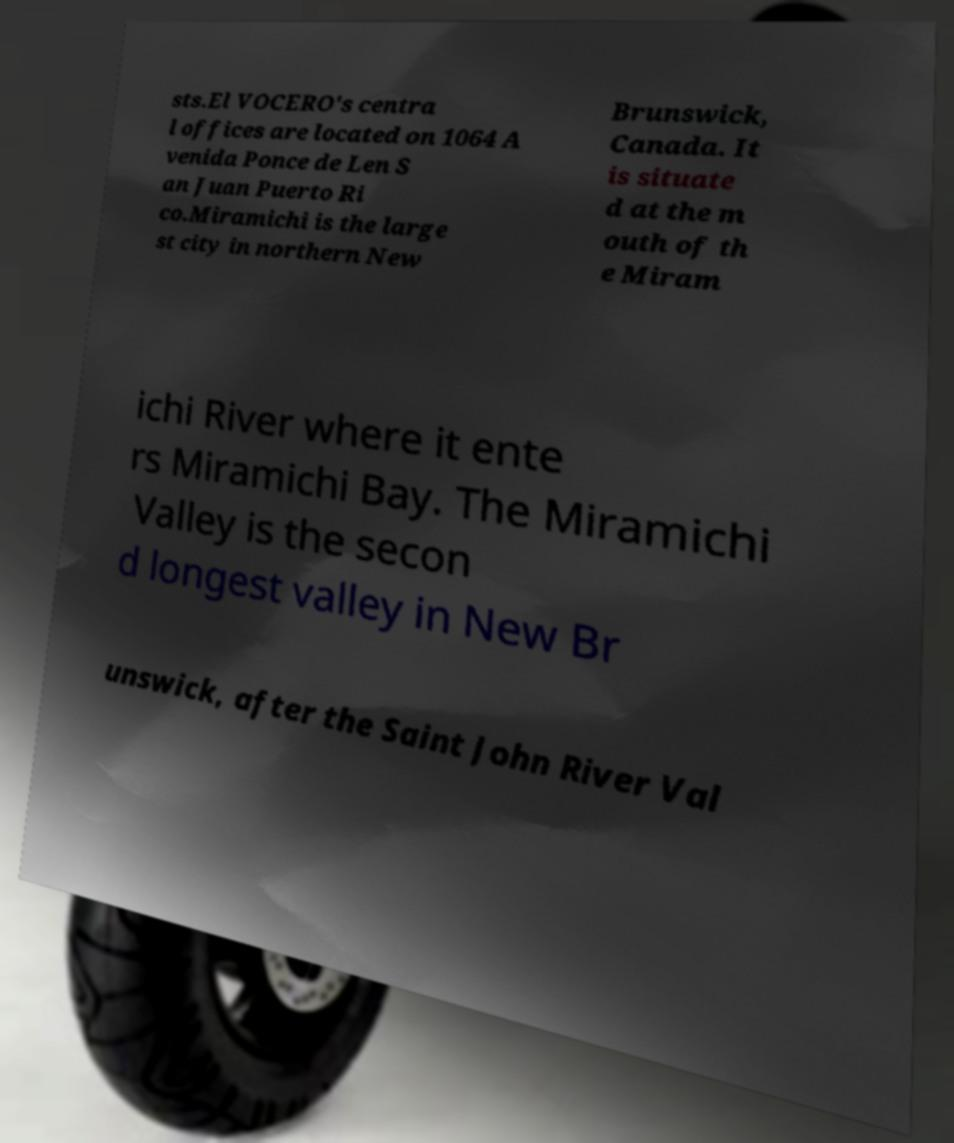Please identify and transcribe the text found in this image. sts.El VOCERO's centra l offices are located on 1064 A venida Ponce de Len S an Juan Puerto Ri co.Miramichi is the large st city in northern New Brunswick, Canada. It is situate d at the m outh of th e Miram ichi River where it ente rs Miramichi Bay. The Miramichi Valley is the secon d longest valley in New Br unswick, after the Saint John River Val 